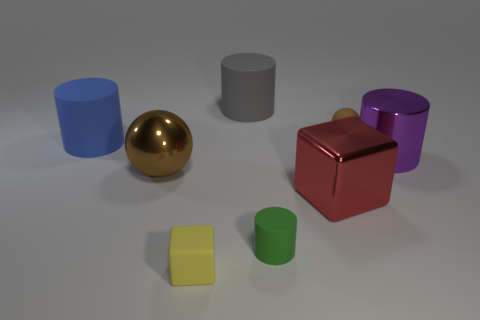Subtract all rubber cylinders. How many cylinders are left? 1 Subtract all green cylinders. How many cylinders are left? 3 Subtract all cyan cylinders. Subtract all red spheres. How many cylinders are left? 4 Add 2 green cylinders. How many objects exist? 10 Subtract all blocks. How many objects are left? 6 Subtract 0 blue spheres. How many objects are left? 8 Subtract all large blue cylinders. Subtract all tiny green objects. How many objects are left? 6 Add 6 small matte balls. How many small matte balls are left? 7 Add 6 small purple rubber cylinders. How many small purple rubber cylinders exist? 6 